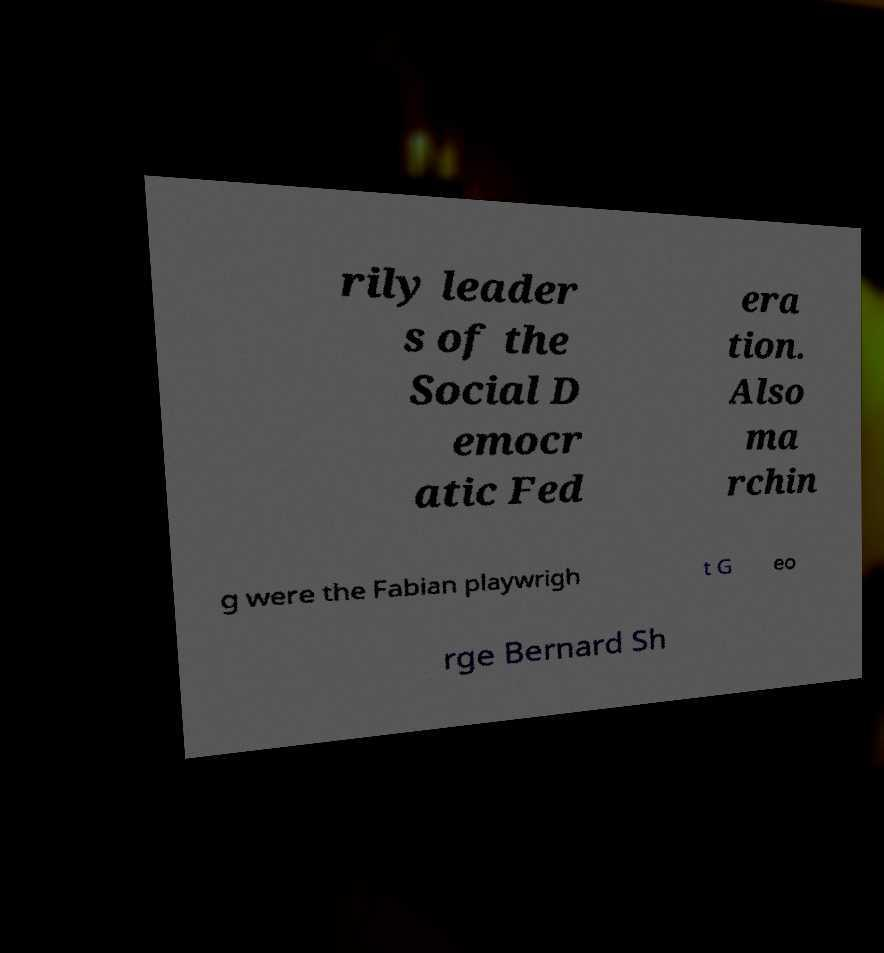Please identify and transcribe the text found in this image. rily leader s of the Social D emocr atic Fed era tion. Also ma rchin g were the Fabian playwrigh t G eo rge Bernard Sh 